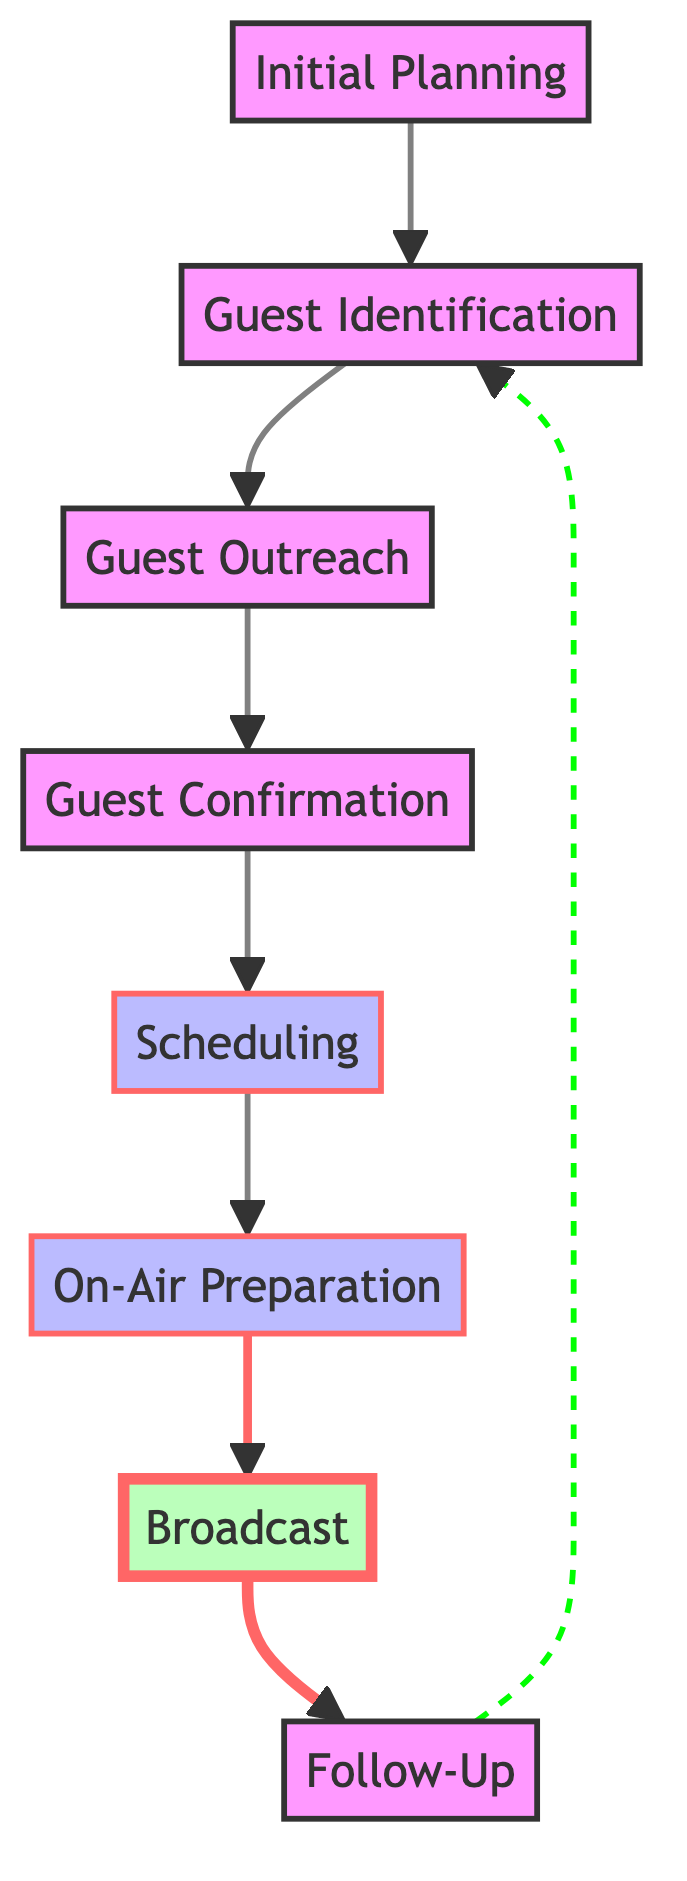What is the first step in the process? The first step in the process according to the diagram is "Initial Planning," which serves as the starting point for subsequent activities.
Answer: Initial Planning How many total elements are in the diagram? By counting the distinct process elements shown in the diagram, we find there are eight elements in total.
Answer: Eight What follows Guest Confirmation in the diagram? The diagram shows that "Guest Confirmation" is directly followed by "Scheduling," indicating that scheduling takes place after confirming the guests' attendance.
Answer: Scheduling Which node is classified as a broadcast? The node labeled "Broadcast" is specifically categorized with a unique color indicating its importance as a broadcasting activity in the live traffic update segments.
Answer: Broadcast Which two nodes are directly linked without a solid connection? The flow from "Follow-Up" to "Guest Identification" is represented with a dashed line, meaning it connects the follow-up process back to the guest identification process.
Answer: Follow-Up and Guest Identification What is the primary purpose of the On-Air Preparation step? The purpose of the "On-Air Preparation" step is to prepare the talking points, questions, and topics for discussion related to traffic updates, ensuring a smooth broadcast.
Answer: Prepare talking points What is the relationship between Initial Planning and Guest Identification? The diagram indicates that "Initial Planning" leads directly to "Guest Identification," showing that planning informs the identification of guests for the show.
Answer: Leads to Which node provides feedback opportunities after the broadcast? The "Follow-Up" node has a defined purpose in the process: it engages with guests post-segment to gather feedback and explore future collaboration opportunities.
Answer: Follow-Up When does Scheduling occur in the overall process? "Scheduling" takes place after "Guest Confirmation," highlighting its position in the sequence before the preparation for the show.
Answer: After Guest Confirmation 